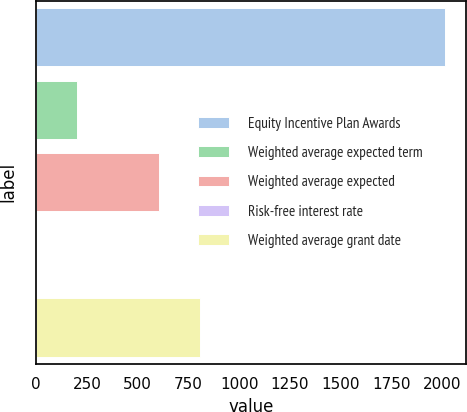<chart> <loc_0><loc_0><loc_500><loc_500><bar_chart><fcel>Equity Incentive Plan Awards<fcel>Weighted average expected term<fcel>Weighted average expected<fcel>Risk-free interest rate<fcel>Weighted average grant date<nl><fcel>2016<fcel>202.79<fcel>605.73<fcel>1.32<fcel>807.2<nl></chart> 